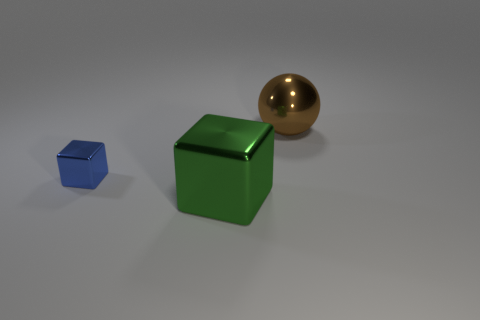Add 3 tiny blue shiny things. How many objects exist? 6 Subtract all cubes. How many objects are left? 1 Add 3 green things. How many green things are left? 4 Add 3 brown metallic cylinders. How many brown metallic cylinders exist? 3 Subtract 0 green cylinders. How many objects are left? 3 Subtract all blue metal blocks. Subtract all big green shiny blocks. How many objects are left? 1 